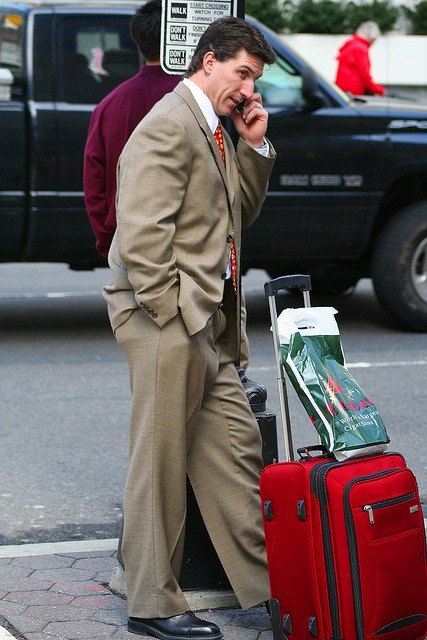Describe the objects in this image and their specific colors. I can see people in lavender, gray, darkgray, and black tones, truck in lavender, black, gray, and darkgray tones, suitcase in lavender, maroon, black, and brown tones, people in lavender, purple, and black tones, and suitcase in lavender, black, gray, and darkgray tones in this image. 